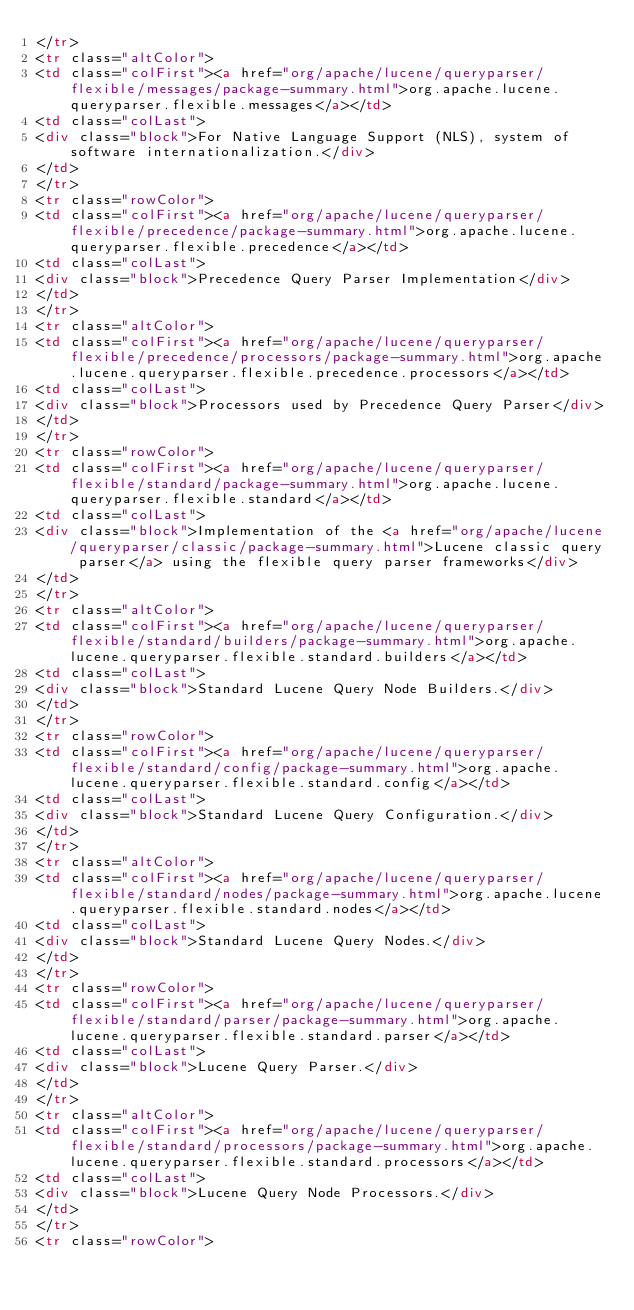<code> <loc_0><loc_0><loc_500><loc_500><_HTML_></tr>
<tr class="altColor">
<td class="colFirst"><a href="org/apache/lucene/queryparser/flexible/messages/package-summary.html">org.apache.lucene.queryparser.flexible.messages</a></td>
<td class="colLast">
<div class="block">For Native Language Support (NLS), system of software internationalization.</div>
</td>
</tr>
<tr class="rowColor">
<td class="colFirst"><a href="org/apache/lucene/queryparser/flexible/precedence/package-summary.html">org.apache.lucene.queryparser.flexible.precedence</a></td>
<td class="colLast">
<div class="block">Precedence Query Parser Implementation</div>
</td>
</tr>
<tr class="altColor">
<td class="colFirst"><a href="org/apache/lucene/queryparser/flexible/precedence/processors/package-summary.html">org.apache.lucene.queryparser.flexible.precedence.processors</a></td>
<td class="colLast">
<div class="block">Processors used by Precedence Query Parser</div>
</td>
</tr>
<tr class="rowColor">
<td class="colFirst"><a href="org/apache/lucene/queryparser/flexible/standard/package-summary.html">org.apache.lucene.queryparser.flexible.standard</a></td>
<td class="colLast">
<div class="block">Implementation of the <a href="org/apache/lucene/queryparser/classic/package-summary.html">Lucene classic query parser</a> using the flexible query parser frameworks</div>
</td>
</tr>
<tr class="altColor">
<td class="colFirst"><a href="org/apache/lucene/queryparser/flexible/standard/builders/package-summary.html">org.apache.lucene.queryparser.flexible.standard.builders</a></td>
<td class="colLast">
<div class="block">Standard Lucene Query Node Builders.</div>
</td>
</tr>
<tr class="rowColor">
<td class="colFirst"><a href="org/apache/lucene/queryparser/flexible/standard/config/package-summary.html">org.apache.lucene.queryparser.flexible.standard.config</a></td>
<td class="colLast">
<div class="block">Standard Lucene Query Configuration.</div>
</td>
</tr>
<tr class="altColor">
<td class="colFirst"><a href="org/apache/lucene/queryparser/flexible/standard/nodes/package-summary.html">org.apache.lucene.queryparser.flexible.standard.nodes</a></td>
<td class="colLast">
<div class="block">Standard Lucene Query Nodes.</div>
</td>
</tr>
<tr class="rowColor">
<td class="colFirst"><a href="org/apache/lucene/queryparser/flexible/standard/parser/package-summary.html">org.apache.lucene.queryparser.flexible.standard.parser</a></td>
<td class="colLast">
<div class="block">Lucene Query Parser.</div>
</td>
</tr>
<tr class="altColor">
<td class="colFirst"><a href="org/apache/lucene/queryparser/flexible/standard/processors/package-summary.html">org.apache.lucene.queryparser.flexible.standard.processors</a></td>
<td class="colLast">
<div class="block">Lucene Query Node Processors.</div>
</td>
</tr>
<tr class="rowColor"></code> 